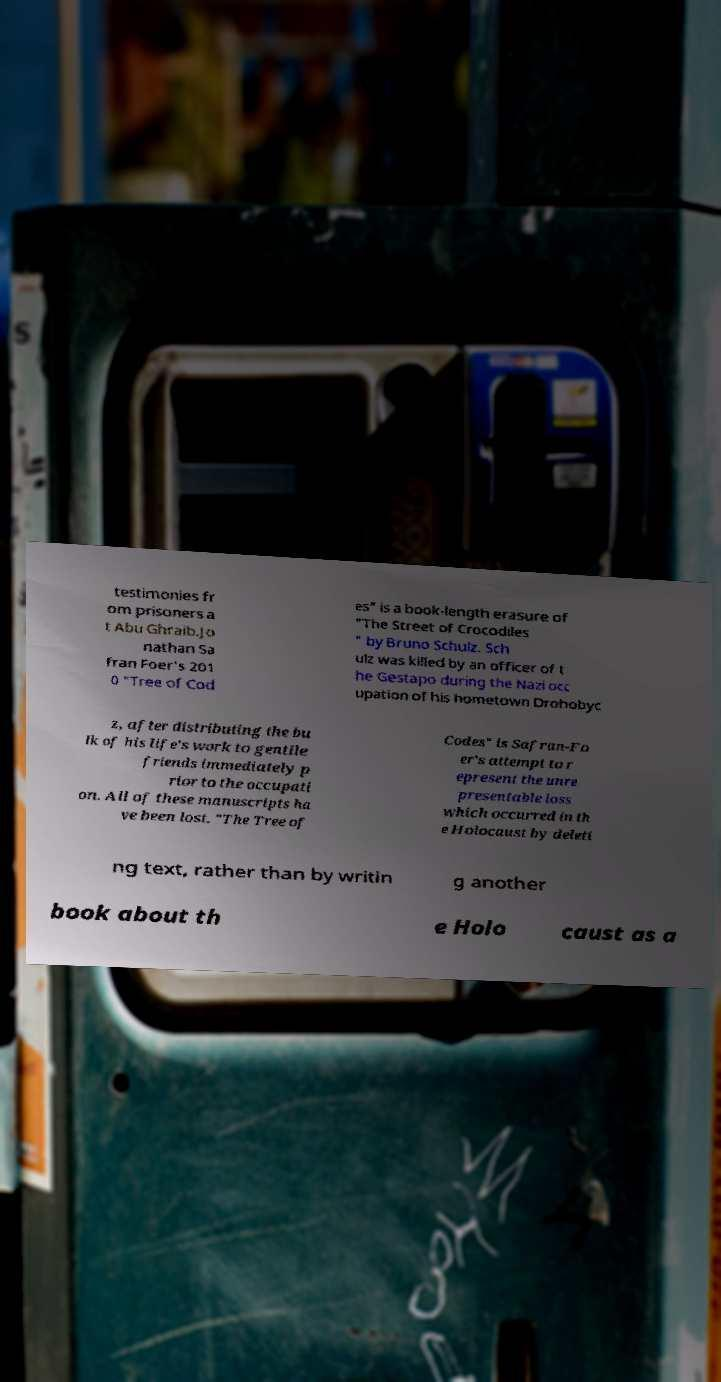For documentation purposes, I need the text within this image transcribed. Could you provide that? testimonies fr om prisoners a t Abu Ghraib.Jo nathan Sa fran Foer's 201 0 "Tree of Cod es" is a book-length erasure of "The Street of Crocodiles " by Bruno Schulz. Sch ulz was killed by an officer of t he Gestapo during the Nazi occ upation of his hometown Drohobyc z, after distributing the bu lk of his life's work to gentile friends immediately p rior to the occupati on. All of these manuscripts ha ve been lost. "The Tree of Codes" is Safran-Fo er's attempt to r epresent the unre presentable loss which occurred in th e Holocaust by deleti ng text, rather than by writin g another book about th e Holo caust as a 